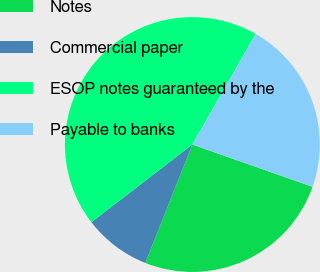Convert chart. <chart><loc_0><loc_0><loc_500><loc_500><pie_chart><fcel>Notes<fcel>Commercial paper<fcel>ESOP notes guaranteed by the<fcel>Payable to banks<nl><fcel>25.63%<fcel>8.54%<fcel>43.72%<fcel>22.11%<nl></chart> 